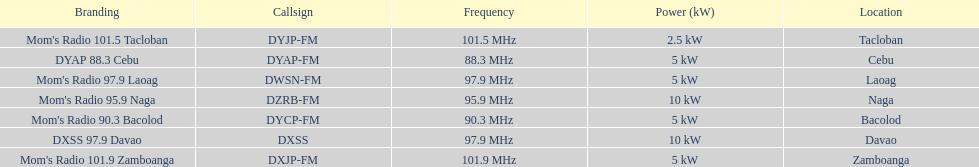What is the radio with the least about of mhz? DYAP 88.3 Cebu. 